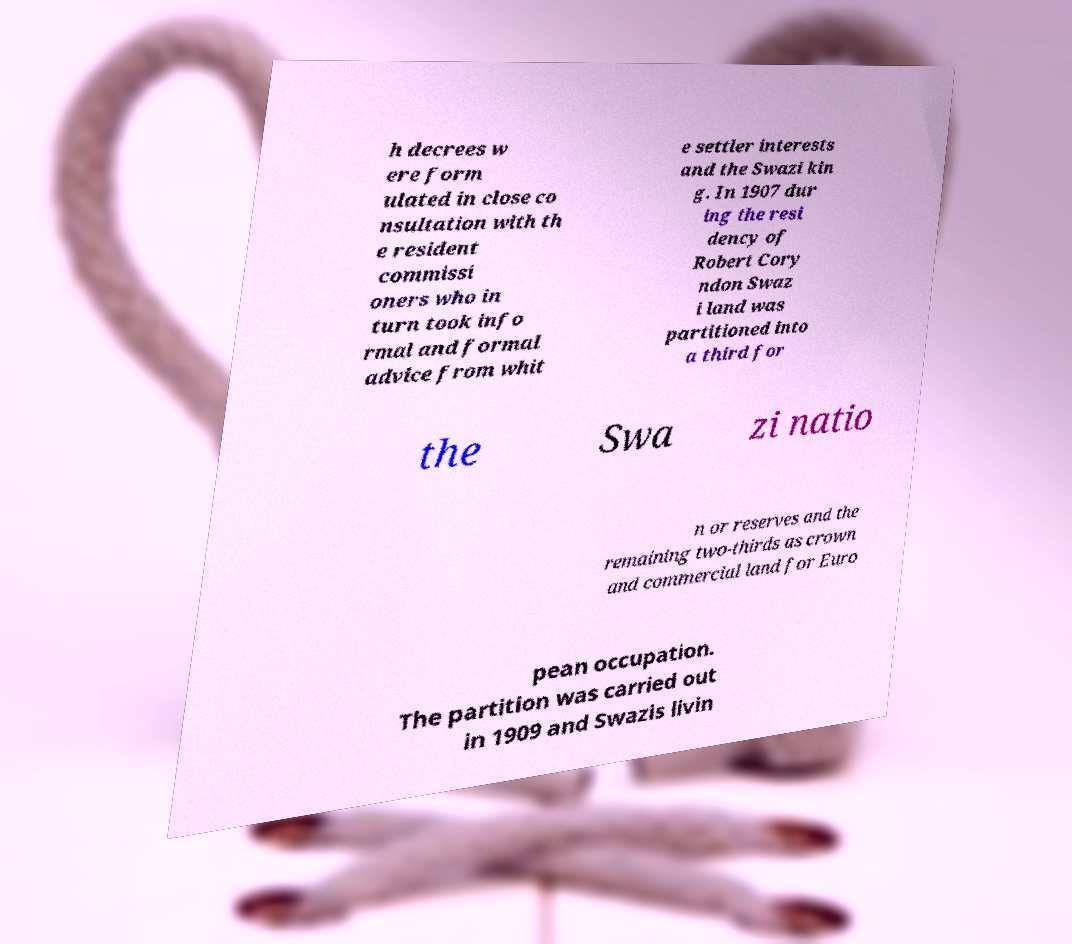For documentation purposes, I need the text within this image transcribed. Could you provide that? h decrees w ere form ulated in close co nsultation with th e resident commissi oners who in turn took info rmal and formal advice from whit e settler interests and the Swazi kin g. In 1907 dur ing the resi dency of Robert Cory ndon Swaz i land was partitioned into a third for the Swa zi natio n or reserves and the remaining two-thirds as crown and commercial land for Euro pean occupation. The partition was carried out in 1909 and Swazis livin 